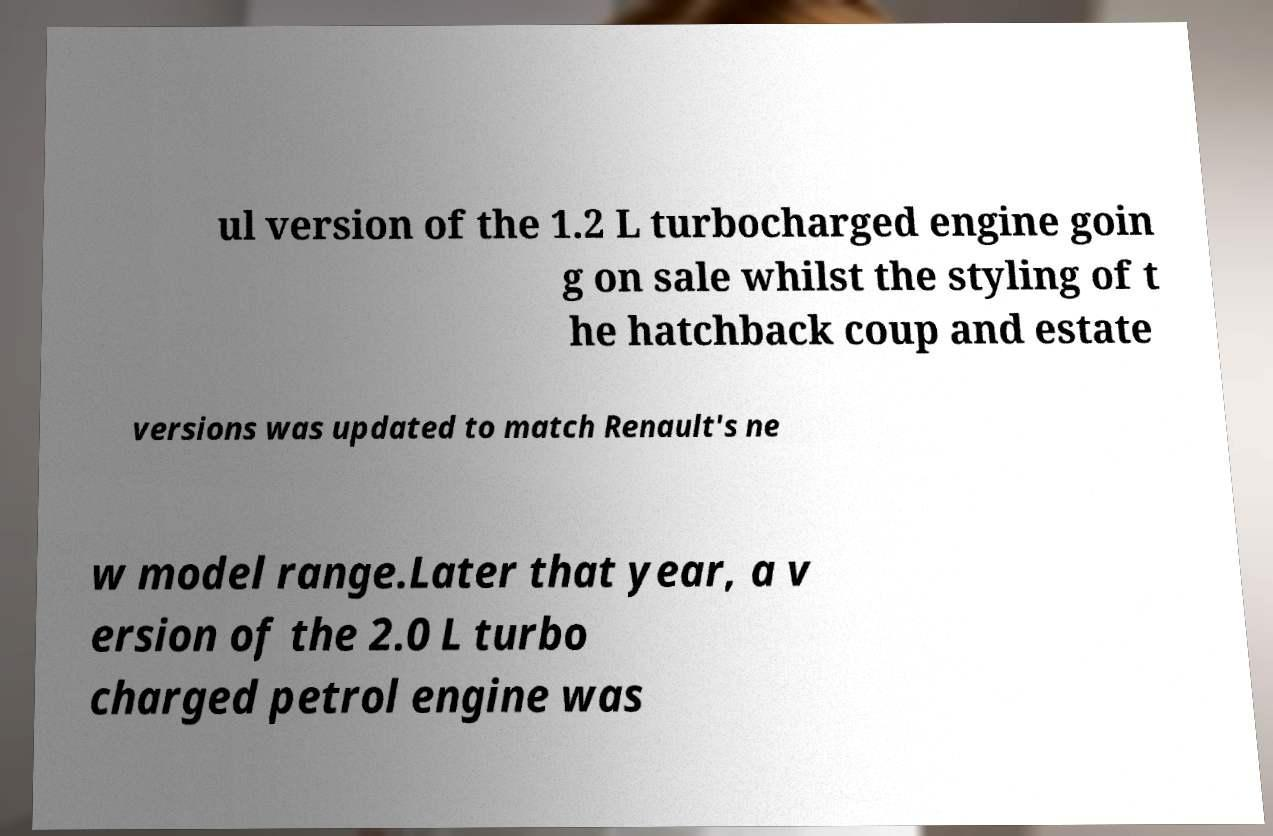Could you extract and type out the text from this image? ul version of the 1.2 L turbocharged engine goin g on sale whilst the styling of t he hatchback coup and estate versions was updated to match Renault's ne w model range.Later that year, a v ersion of the 2.0 L turbo charged petrol engine was 